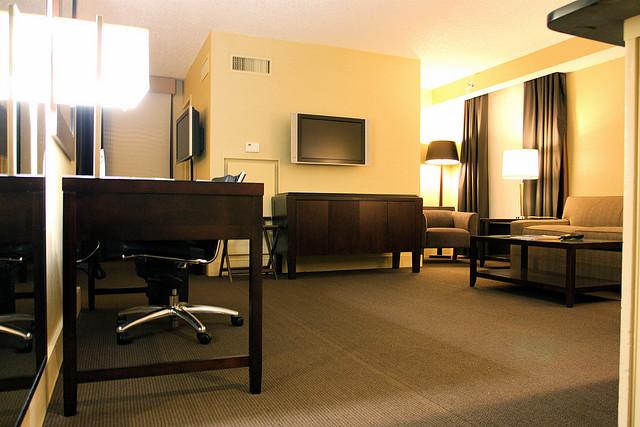Does this room appear clean?
Quick response, please. Yes. Is this a modern room?
Concise answer only. Yes. Are the lamps turned on?
Write a very short answer. Yes. 